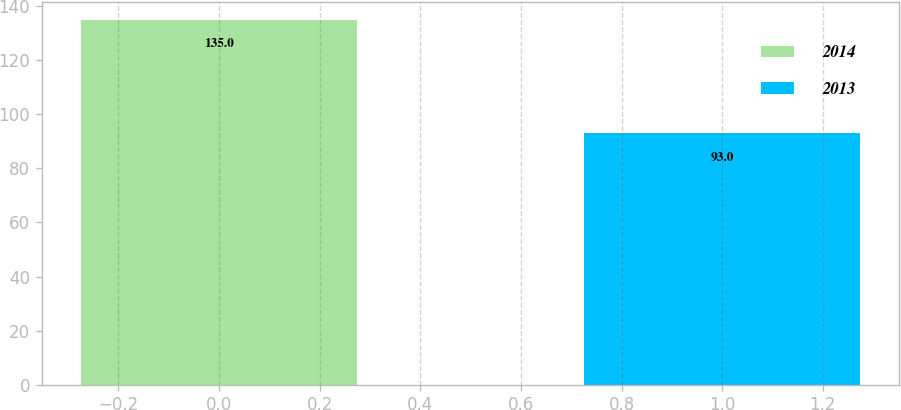<chart> <loc_0><loc_0><loc_500><loc_500><bar_chart><fcel>2014<fcel>2013<nl><fcel>135<fcel>93<nl></chart> 